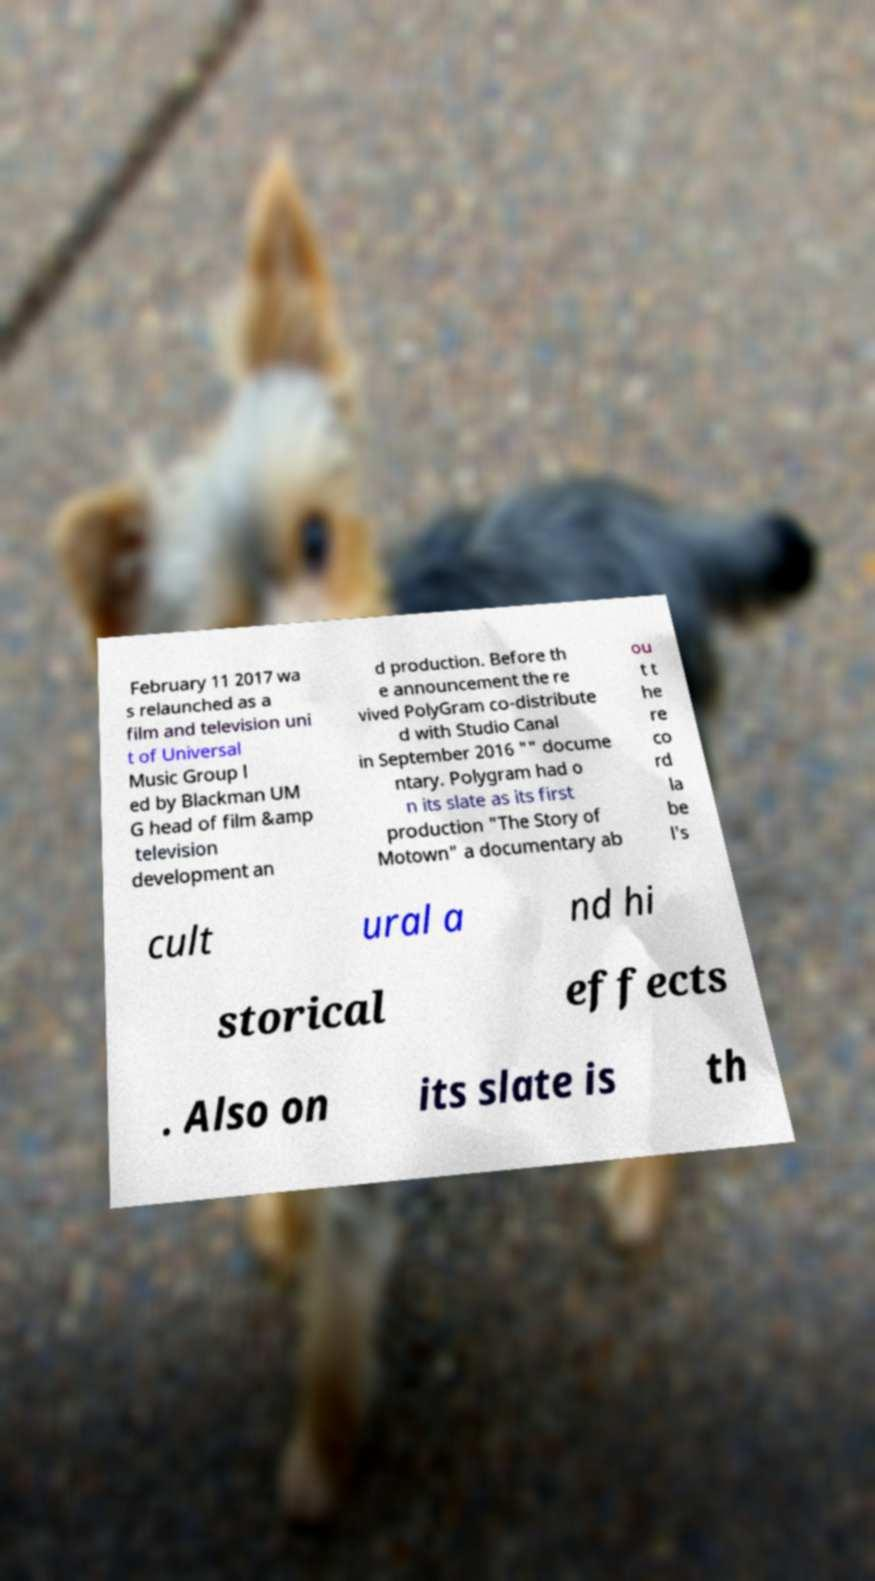Can you read and provide the text displayed in the image?This photo seems to have some interesting text. Can you extract and type it out for me? February 11 2017 wa s relaunched as a film and television uni t of Universal Music Group l ed by Blackman UM G head of film &amp television development an d production. Before th e announcement the re vived PolyGram co-distribute d with Studio Canal in September 2016 "" docume ntary. Polygram had o n its slate as its first production "The Story of Motown" a documentary ab ou t t he re co rd la be l's cult ural a nd hi storical effects . Also on its slate is th 